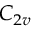Convert formula to latex. <formula><loc_0><loc_0><loc_500><loc_500>C _ { 2 v }</formula> 